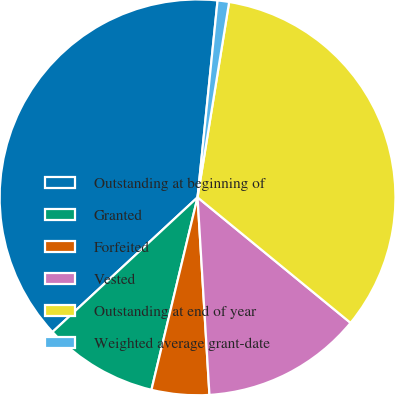<chart> <loc_0><loc_0><loc_500><loc_500><pie_chart><fcel>Outstanding at beginning of<fcel>Granted<fcel>Forfeited<fcel>Vested<fcel>Outstanding at end of year<fcel>Weighted average grant-date<nl><fcel>38.52%<fcel>9.35%<fcel>4.7%<fcel>13.11%<fcel>33.38%<fcel>0.94%<nl></chart> 